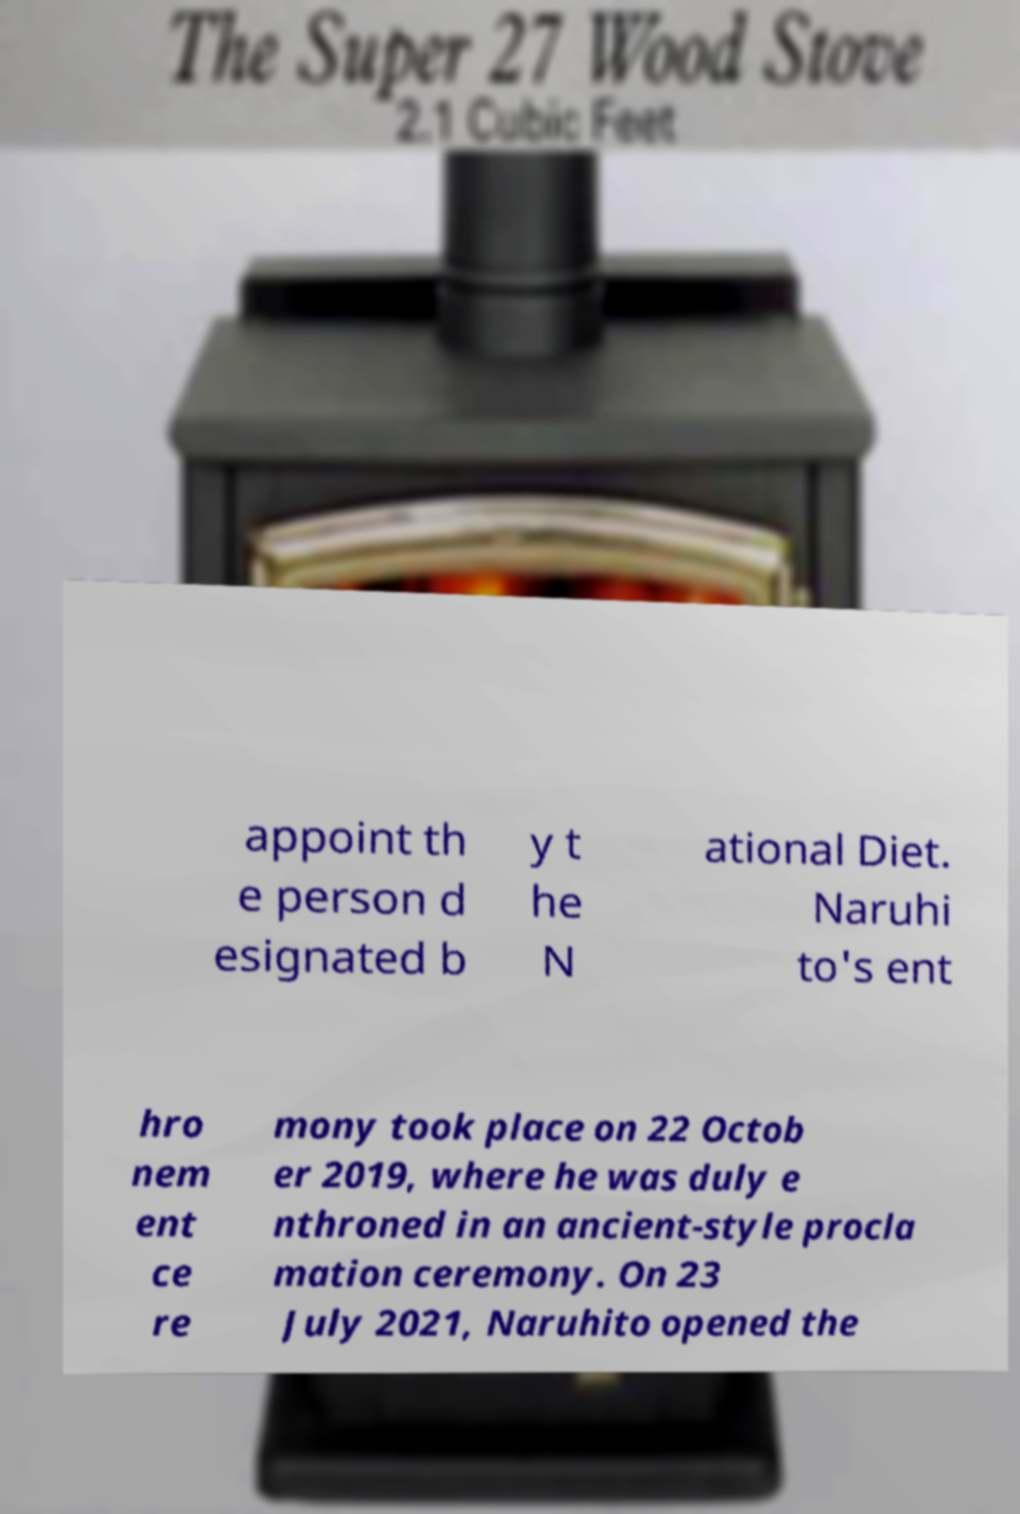Could you assist in decoding the text presented in this image and type it out clearly? appoint th e person d esignated b y t he N ational Diet. Naruhi to's ent hro nem ent ce re mony took place on 22 Octob er 2019, where he was duly e nthroned in an ancient-style procla mation ceremony. On 23 July 2021, Naruhito opened the 